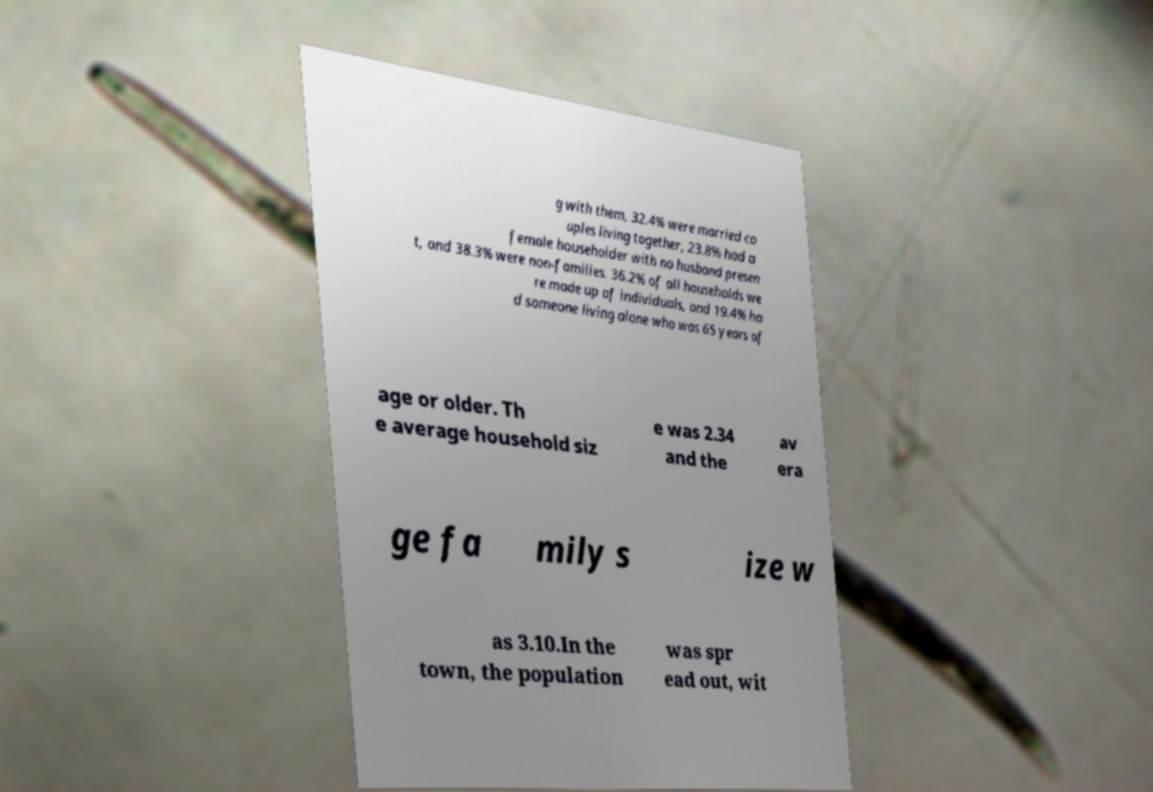What messages or text are displayed in this image? I need them in a readable, typed format. g with them, 32.4% were married co uples living together, 23.8% had a female householder with no husband presen t, and 38.3% were non-families. 36.2% of all households we re made up of individuals, and 19.4% ha d someone living alone who was 65 years of age or older. Th e average household siz e was 2.34 and the av era ge fa mily s ize w as 3.10.In the town, the population was spr ead out, wit 